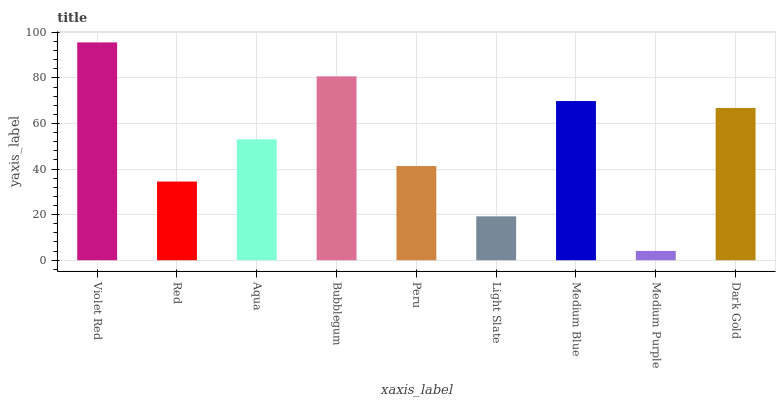Is Medium Purple the minimum?
Answer yes or no. Yes. Is Violet Red the maximum?
Answer yes or no. Yes. Is Red the minimum?
Answer yes or no. No. Is Red the maximum?
Answer yes or no. No. Is Violet Red greater than Red?
Answer yes or no. Yes. Is Red less than Violet Red?
Answer yes or no. Yes. Is Red greater than Violet Red?
Answer yes or no. No. Is Violet Red less than Red?
Answer yes or no. No. Is Aqua the high median?
Answer yes or no. Yes. Is Aqua the low median?
Answer yes or no. Yes. Is Violet Red the high median?
Answer yes or no. No. Is Medium Purple the low median?
Answer yes or no. No. 